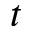Convert formula to latex. <formula><loc_0><loc_0><loc_500><loc_500>t</formula> 